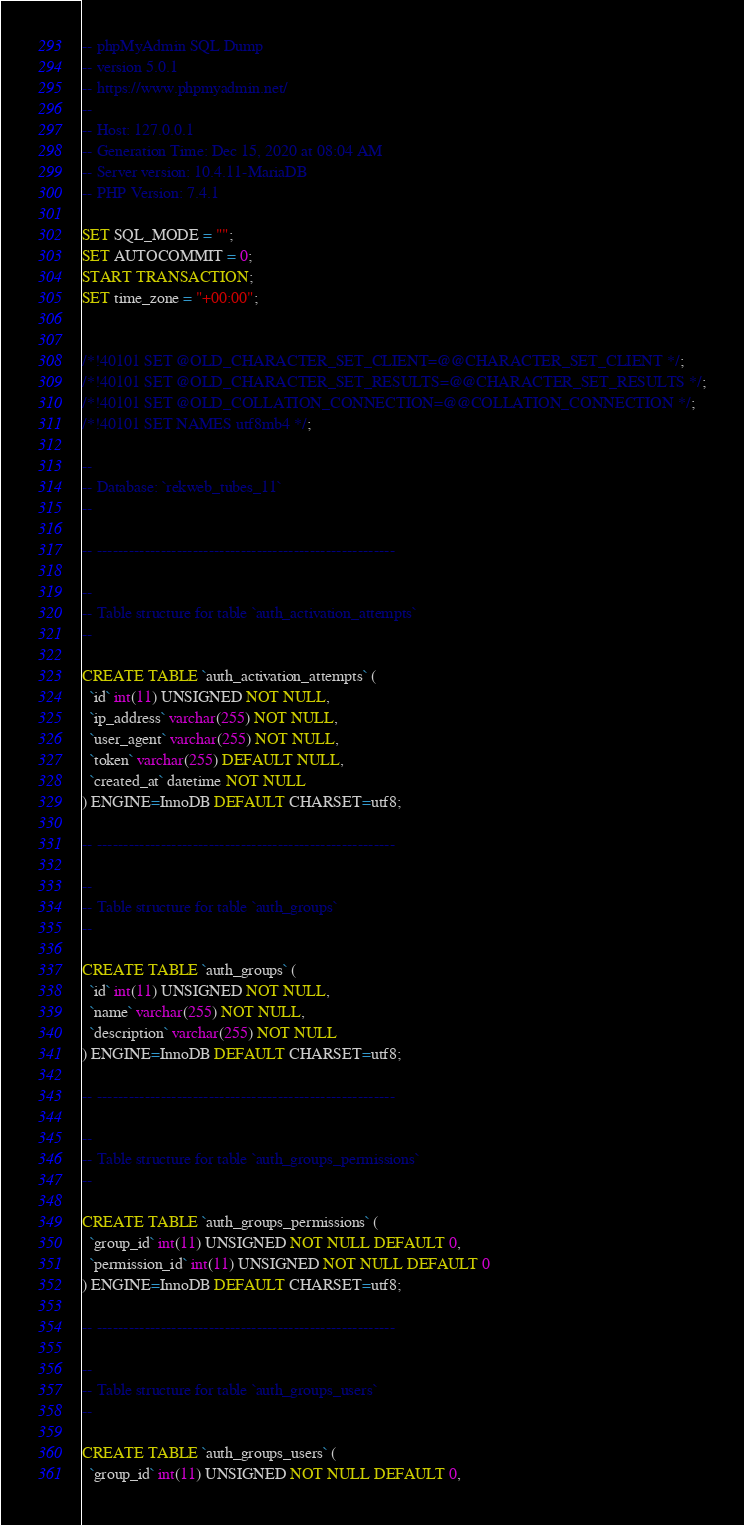Convert code to text. <code><loc_0><loc_0><loc_500><loc_500><_SQL_>-- phpMyAdmin SQL Dump
-- version 5.0.1
-- https://www.phpmyadmin.net/
--
-- Host: 127.0.0.1
-- Generation Time: Dec 15, 2020 at 08:04 AM
-- Server version: 10.4.11-MariaDB
-- PHP Version: 7.4.1

SET SQL_MODE = "";
SET AUTOCOMMIT = 0;
START TRANSACTION;
SET time_zone = "+00:00";


/*!40101 SET @OLD_CHARACTER_SET_CLIENT=@@CHARACTER_SET_CLIENT */;
/*!40101 SET @OLD_CHARACTER_SET_RESULTS=@@CHARACTER_SET_RESULTS */;
/*!40101 SET @OLD_COLLATION_CONNECTION=@@COLLATION_CONNECTION */;
/*!40101 SET NAMES utf8mb4 */;

--
-- Database: `rekweb_tubes_11`
--

-- --------------------------------------------------------

--
-- Table structure for table `auth_activation_attempts`
--

CREATE TABLE `auth_activation_attempts` (
  `id` int(11) UNSIGNED NOT NULL,
  `ip_address` varchar(255) NOT NULL,
  `user_agent` varchar(255) NOT NULL,
  `token` varchar(255) DEFAULT NULL,
  `created_at` datetime NOT NULL
) ENGINE=InnoDB DEFAULT CHARSET=utf8;

-- --------------------------------------------------------

--
-- Table structure for table `auth_groups`
--

CREATE TABLE `auth_groups` (
  `id` int(11) UNSIGNED NOT NULL,
  `name` varchar(255) NOT NULL,
  `description` varchar(255) NOT NULL
) ENGINE=InnoDB DEFAULT CHARSET=utf8;

-- --------------------------------------------------------

--
-- Table structure for table `auth_groups_permissions`
--

CREATE TABLE `auth_groups_permissions` (
  `group_id` int(11) UNSIGNED NOT NULL DEFAULT 0,
  `permission_id` int(11) UNSIGNED NOT NULL DEFAULT 0
) ENGINE=InnoDB DEFAULT CHARSET=utf8;

-- --------------------------------------------------------

--
-- Table structure for table `auth_groups_users`
--

CREATE TABLE `auth_groups_users` (
  `group_id` int(11) UNSIGNED NOT NULL DEFAULT 0,</code> 